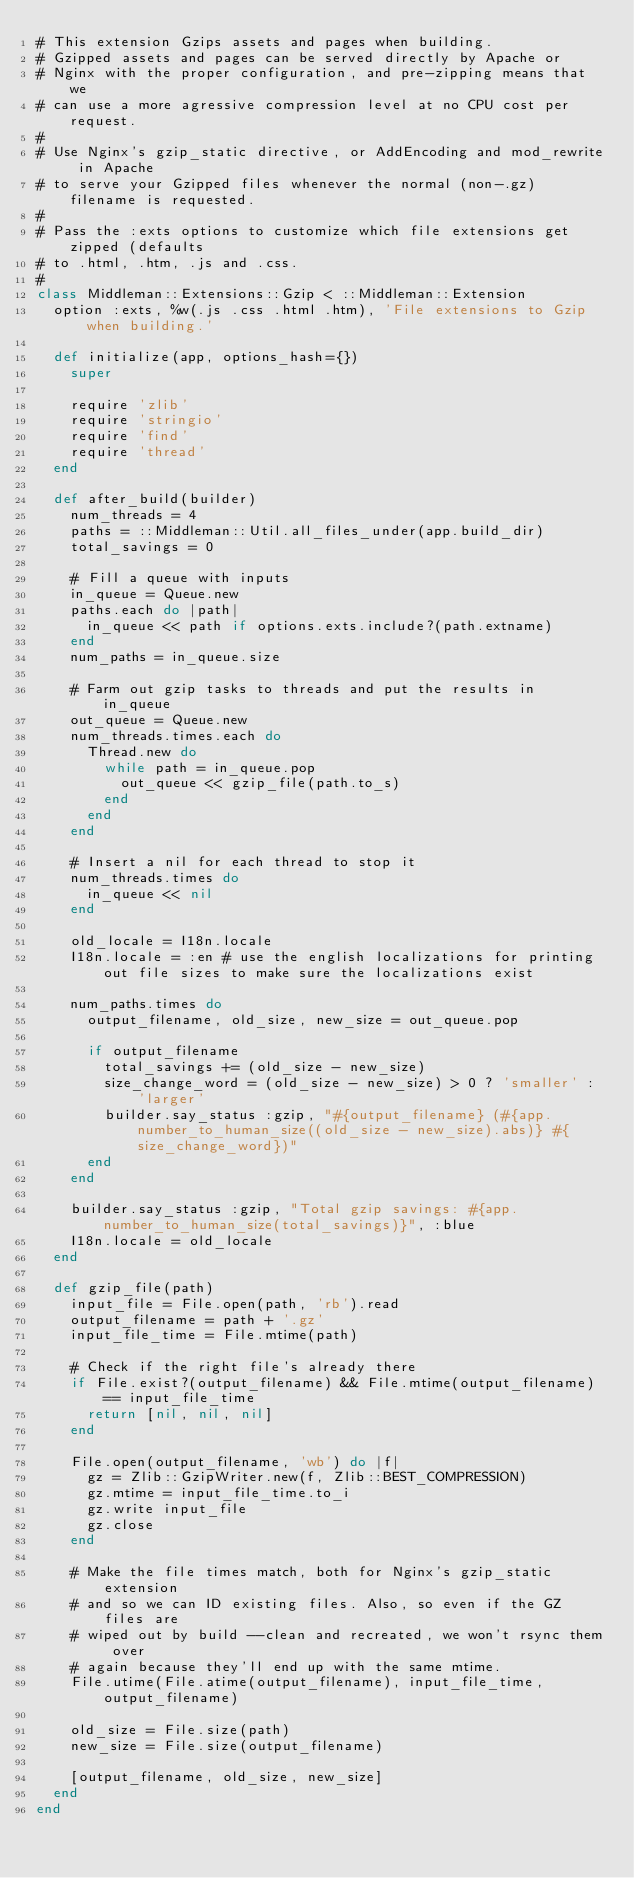Convert code to text. <code><loc_0><loc_0><loc_500><loc_500><_Ruby_># This extension Gzips assets and pages when building.
# Gzipped assets and pages can be served directly by Apache or
# Nginx with the proper configuration, and pre-zipping means that we
# can use a more agressive compression level at no CPU cost per request.
#
# Use Nginx's gzip_static directive, or AddEncoding and mod_rewrite in Apache
# to serve your Gzipped files whenever the normal (non-.gz) filename is requested.
#
# Pass the :exts options to customize which file extensions get zipped (defaults
# to .html, .htm, .js and .css.
#
class Middleman::Extensions::Gzip < ::Middleman::Extension
  option :exts, %w(.js .css .html .htm), 'File extensions to Gzip when building.'

  def initialize(app, options_hash={})
    super

    require 'zlib'
    require 'stringio'
    require 'find'
    require 'thread'
  end

  def after_build(builder)
    num_threads = 4
    paths = ::Middleman::Util.all_files_under(app.build_dir)
    total_savings = 0

    # Fill a queue with inputs
    in_queue = Queue.new
    paths.each do |path|
      in_queue << path if options.exts.include?(path.extname)
    end
    num_paths = in_queue.size

    # Farm out gzip tasks to threads and put the results in in_queue
    out_queue = Queue.new
    num_threads.times.each do
      Thread.new do
        while path = in_queue.pop
          out_queue << gzip_file(path.to_s)
        end
      end
    end

    # Insert a nil for each thread to stop it
    num_threads.times do
      in_queue << nil
    end

    old_locale = I18n.locale
    I18n.locale = :en # use the english localizations for printing out file sizes to make sure the localizations exist

    num_paths.times do
      output_filename, old_size, new_size = out_queue.pop

      if output_filename
        total_savings += (old_size - new_size)
        size_change_word = (old_size - new_size) > 0 ? 'smaller' : 'larger'
        builder.say_status :gzip, "#{output_filename} (#{app.number_to_human_size((old_size - new_size).abs)} #{size_change_word})"
      end
    end

    builder.say_status :gzip, "Total gzip savings: #{app.number_to_human_size(total_savings)}", :blue
    I18n.locale = old_locale
  end

  def gzip_file(path)
    input_file = File.open(path, 'rb').read
    output_filename = path + '.gz'
    input_file_time = File.mtime(path)

    # Check if the right file's already there
    if File.exist?(output_filename) && File.mtime(output_filename) == input_file_time
      return [nil, nil, nil]
    end

    File.open(output_filename, 'wb') do |f|
      gz = Zlib::GzipWriter.new(f, Zlib::BEST_COMPRESSION)
      gz.mtime = input_file_time.to_i
      gz.write input_file
      gz.close
    end

    # Make the file times match, both for Nginx's gzip_static extension
    # and so we can ID existing files. Also, so even if the GZ files are
    # wiped out by build --clean and recreated, we won't rsync them over
    # again because they'll end up with the same mtime.
    File.utime(File.atime(output_filename), input_file_time, output_filename)

    old_size = File.size(path)
    new_size = File.size(output_filename)

    [output_filename, old_size, new_size]
  end
end
</code> 